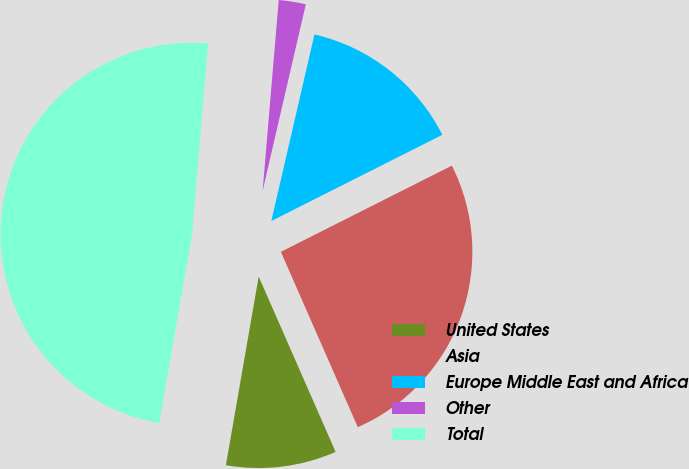Convert chart. <chart><loc_0><loc_0><loc_500><loc_500><pie_chart><fcel>United States<fcel>Asia<fcel>Europe Middle East and Africa<fcel>Other<fcel>Total<nl><fcel>9.32%<fcel>25.85%<fcel>13.95%<fcel>2.28%<fcel>48.6%<nl></chart> 